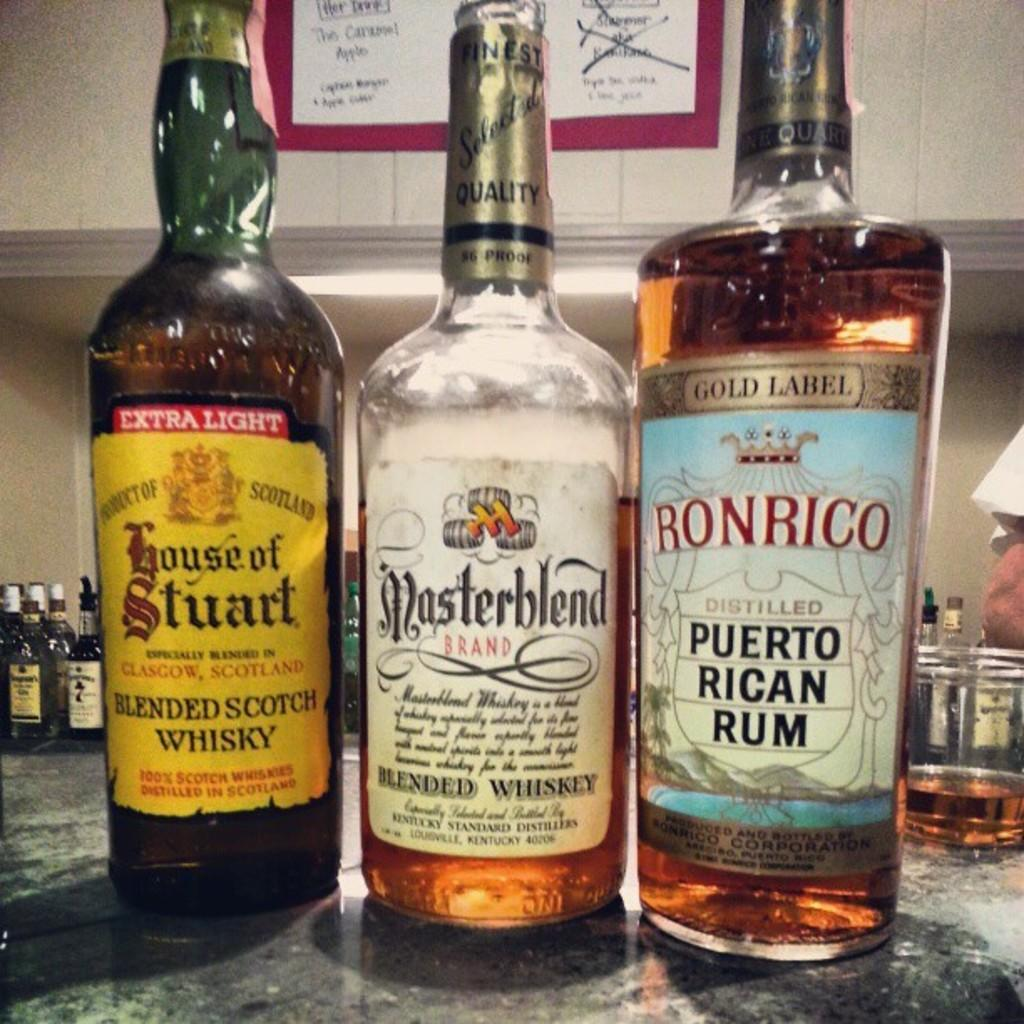Provide a one-sentence caption for the provided image. Bottles of whisky include House of Stuart, Masterblend and Ronrico on their labels. 